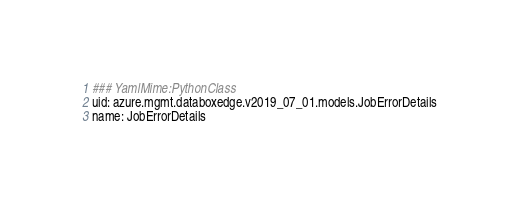Convert code to text. <code><loc_0><loc_0><loc_500><loc_500><_YAML_>### YamlMime:PythonClass
uid: azure.mgmt.databoxedge.v2019_07_01.models.JobErrorDetails
name: JobErrorDetails</code> 